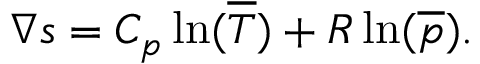Convert formula to latex. <formula><loc_0><loc_0><loc_500><loc_500>\nabla s = C _ { p } \ln ( { \overline { T } } ) + R \ln ( { \overline { p } } ) .</formula> 